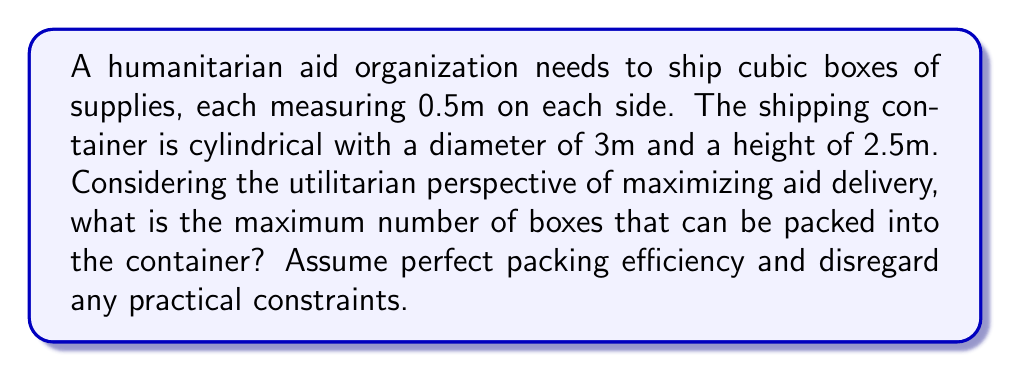Solve this math problem. To solve this problem, we need to compare the volume of the cylindrical container with the volume of the cubic boxes:

1. Calculate the volume of the cylindrical container:
   $$V_{cylinder} = \pi r^2 h$$
   where $r$ is the radius and $h$ is the height
   $$V_{cylinder} = \pi \cdot (1.5m)^2 \cdot 2.5m = 17.67m^3$$

2. Calculate the volume of each cubic box:
   $$V_{box} = 0.5m \cdot 0.5m \cdot 0.5m = 0.125m^3$$

3. Calculate the maximum number of boxes:
   $$N_{boxes} = \frac{V_{cylinder}}{V_{box}} = \frac{17.67m^3}{0.125m^3} = 141.36$$

4. Since we can't have a fractional number of boxes, we round down to the nearest whole number.

This solution assumes perfect packing efficiency, which is theoretically possible but practically challenging. It disregards factors such as box arrangement, air gaps, or structural integrity of the stack. From a utilitarian perspective, this approach maximizes the potential aid delivered, even if it might pose practical challenges in implementation.
Answer: The maximum number of boxes that can be packed into the container is 141. 